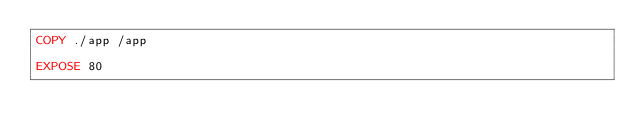<code> <loc_0><loc_0><loc_500><loc_500><_Dockerfile_>COPY ./app /app

EXPOSE 80</code> 